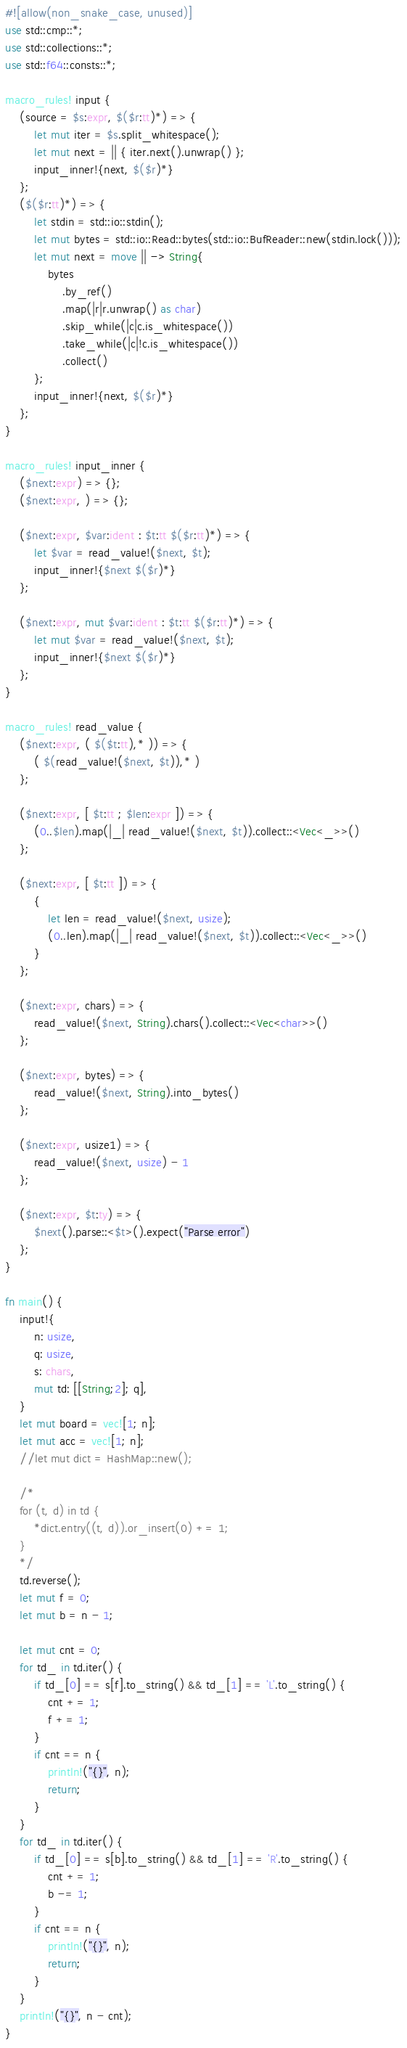Convert code to text. <code><loc_0><loc_0><loc_500><loc_500><_Rust_>#![allow(non_snake_case, unused)]
use std::cmp::*;
use std::collections::*;
use std::f64::consts::*;

macro_rules! input {
    (source = $s:expr, $($r:tt)*) => {
        let mut iter = $s.split_whitespace();
        let mut next = || { iter.next().unwrap() };
        input_inner!{next, $($r)*}
    };
    ($($r:tt)*) => {
        let stdin = std::io::stdin();
        let mut bytes = std::io::Read::bytes(std::io::BufReader::new(stdin.lock()));
        let mut next = move || -> String{
            bytes
                .by_ref()
                .map(|r|r.unwrap() as char)
                .skip_while(|c|c.is_whitespace())
                .take_while(|c|!c.is_whitespace())
                .collect()
        };
        input_inner!{next, $($r)*}
    };
}

macro_rules! input_inner {
    ($next:expr) => {};
    ($next:expr, ) => {};

    ($next:expr, $var:ident : $t:tt $($r:tt)*) => {
        let $var = read_value!($next, $t);
        input_inner!{$next $($r)*}
    };

    ($next:expr, mut $var:ident : $t:tt $($r:tt)*) => {
        let mut $var = read_value!($next, $t);
        input_inner!{$next $($r)*}
    };
}

macro_rules! read_value {
    ($next:expr, ( $($t:tt),* )) => {
        ( $(read_value!($next, $t)),* )
    };

    ($next:expr, [ $t:tt ; $len:expr ]) => {
        (0..$len).map(|_| read_value!($next, $t)).collect::<Vec<_>>()
    };

    ($next:expr, [ $t:tt ]) => {
        {
            let len = read_value!($next, usize);
            (0..len).map(|_| read_value!($next, $t)).collect::<Vec<_>>()
        }
    };

    ($next:expr, chars) => {
        read_value!($next, String).chars().collect::<Vec<char>>()
    };

    ($next:expr, bytes) => {
        read_value!($next, String).into_bytes()
    };

    ($next:expr, usize1) => {
        read_value!($next, usize) - 1
    };

    ($next:expr, $t:ty) => {
        $next().parse::<$t>().expect("Parse error")
    };
}

fn main() {
    input!{
        n: usize,
        q: usize,
        s: chars,
        mut td: [[String;2]; q],
    }
    let mut board = vec![1; n];
    let mut acc = vec![1; n];
    //let mut dict = HashMap::new();

    /*
    for (t, d) in td {
        *dict.entry((t, d)).or_insert(0) += 1;
    }
    */
    td.reverse();
    let mut f = 0;
    let mut b = n - 1;

    let mut cnt = 0;
    for td_ in td.iter() {
        if td_[0] == s[f].to_string() && td_[1] == 'L'.to_string() {
            cnt += 1;
            f += 1;
        }
        if cnt == n {
            println!("{}", n);
            return;
        }
    }
    for td_ in td.iter() {
        if td_[0] == s[b].to_string() && td_[1] == 'R'.to_string() {
            cnt += 1;
            b -= 1;
        }
        if cnt == n {
            println!("{}", n);
            return;
        }
    }
    println!("{}", n - cnt);
}
</code> 